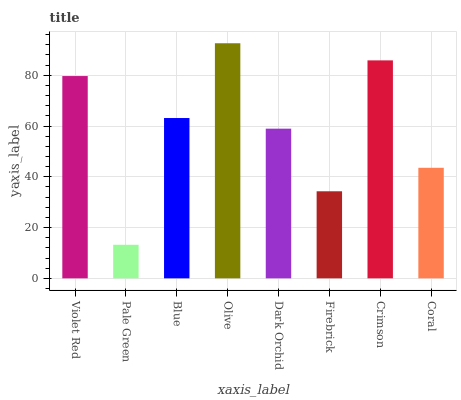Is Blue the minimum?
Answer yes or no. No. Is Blue the maximum?
Answer yes or no. No. Is Blue greater than Pale Green?
Answer yes or no. Yes. Is Pale Green less than Blue?
Answer yes or no. Yes. Is Pale Green greater than Blue?
Answer yes or no. No. Is Blue less than Pale Green?
Answer yes or no. No. Is Blue the high median?
Answer yes or no. Yes. Is Dark Orchid the low median?
Answer yes or no. Yes. Is Firebrick the high median?
Answer yes or no. No. Is Coral the low median?
Answer yes or no. No. 